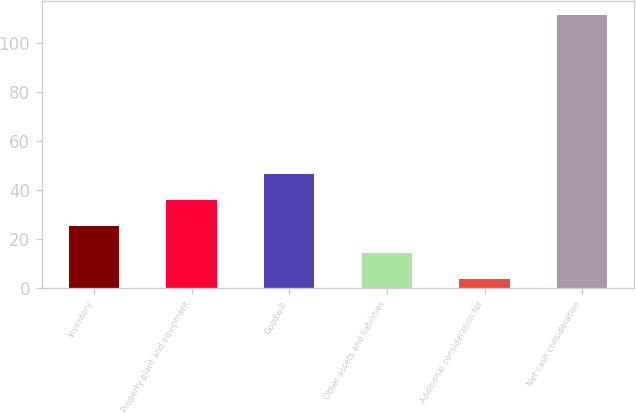Convert chart to OTSL. <chart><loc_0><loc_0><loc_500><loc_500><bar_chart><fcel>Inventory<fcel>Property plant and equipment<fcel>Goodwill<fcel>Other assets and liabilities<fcel>Additional consideration for<fcel>Net cash consideration<nl><fcel>25.14<fcel>35.91<fcel>46.68<fcel>14.37<fcel>3.6<fcel>111.3<nl></chart> 